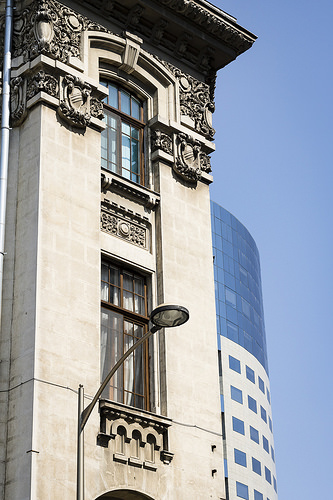<image>
Can you confirm if the building is in front of the sky? No. The building is not in front of the sky. The spatial positioning shows a different relationship between these objects. 